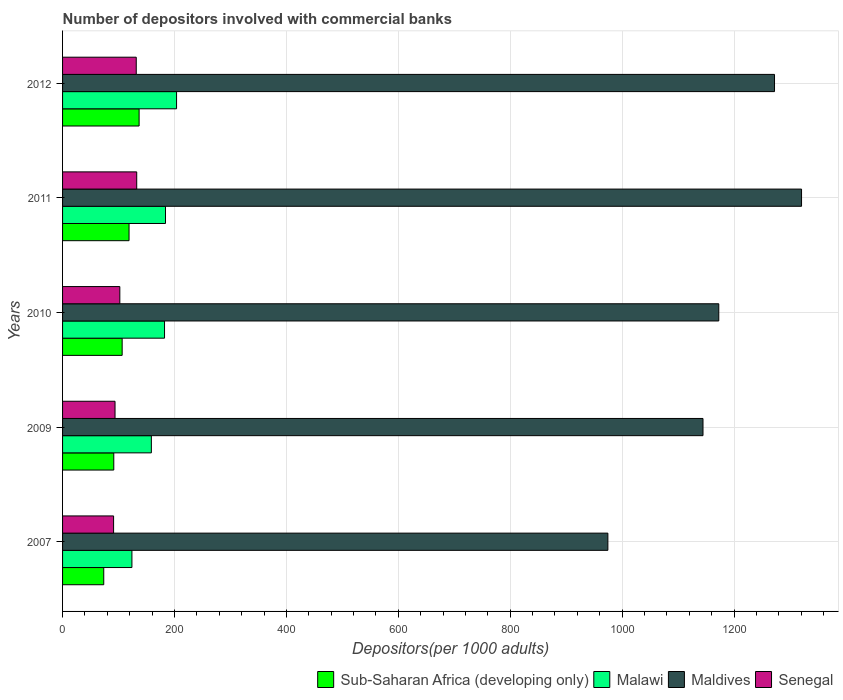Are the number of bars on each tick of the Y-axis equal?
Your response must be concise. Yes. How many bars are there on the 3rd tick from the top?
Keep it short and to the point. 4. In how many cases, is the number of bars for a given year not equal to the number of legend labels?
Offer a very short reply. 0. What is the number of depositors involved with commercial banks in Sub-Saharan Africa (developing only) in 2011?
Your response must be concise. 118.8. Across all years, what is the maximum number of depositors involved with commercial banks in Senegal?
Keep it short and to the point. 132.54. Across all years, what is the minimum number of depositors involved with commercial banks in Maldives?
Ensure brevity in your answer.  974.56. In which year was the number of depositors involved with commercial banks in Sub-Saharan Africa (developing only) maximum?
Provide a short and direct response. 2012. In which year was the number of depositors involved with commercial banks in Maldives minimum?
Give a very brief answer. 2007. What is the total number of depositors involved with commercial banks in Senegal in the graph?
Offer a very short reply. 551.53. What is the difference between the number of depositors involved with commercial banks in Maldives in 2007 and that in 2012?
Your response must be concise. -297.83. What is the difference between the number of depositors involved with commercial banks in Malawi in 2010 and the number of depositors involved with commercial banks in Maldives in 2011?
Provide a short and direct response. -1138.46. What is the average number of depositors involved with commercial banks in Senegal per year?
Keep it short and to the point. 110.31. In the year 2009, what is the difference between the number of depositors involved with commercial banks in Senegal and number of depositors involved with commercial banks in Malawi?
Offer a terse response. -64.92. What is the ratio of the number of depositors involved with commercial banks in Malawi in 2010 to that in 2012?
Offer a terse response. 0.89. Is the difference between the number of depositors involved with commercial banks in Senegal in 2010 and 2012 greater than the difference between the number of depositors involved with commercial banks in Malawi in 2010 and 2012?
Offer a very short reply. No. What is the difference between the highest and the second highest number of depositors involved with commercial banks in Sub-Saharan Africa (developing only)?
Provide a succinct answer. 17.98. What is the difference between the highest and the lowest number of depositors involved with commercial banks in Malawi?
Your answer should be very brief. 79.77. In how many years, is the number of depositors involved with commercial banks in Senegal greater than the average number of depositors involved with commercial banks in Senegal taken over all years?
Offer a terse response. 2. Is it the case that in every year, the sum of the number of depositors involved with commercial banks in Sub-Saharan Africa (developing only) and number of depositors involved with commercial banks in Senegal is greater than the sum of number of depositors involved with commercial banks in Malawi and number of depositors involved with commercial banks in Maldives?
Provide a succinct answer. No. What does the 4th bar from the top in 2012 represents?
Your answer should be very brief. Sub-Saharan Africa (developing only). What does the 2nd bar from the bottom in 2011 represents?
Provide a succinct answer. Malawi. Is it the case that in every year, the sum of the number of depositors involved with commercial banks in Senegal and number of depositors involved with commercial banks in Maldives is greater than the number of depositors involved with commercial banks in Sub-Saharan Africa (developing only)?
Make the answer very short. Yes. Are all the bars in the graph horizontal?
Keep it short and to the point. Yes. Does the graph contain grids?
Your answer should be compact. Yes. Where does the legend appear in the graph?
Provide a short and direct response. Bottom right. How are the legend labels stacked?
Your answer should be very brief. Horizontal. What is the title of the graph?
Offer a terse response. Number of depositors involved with commercial banks. What is the label or title of the X-axis?
Your answer should be compact. Depositors(per 1000 adults). What is the label or title of the Y-axis?
Offer a terse response. Years. What is the Depositors(per 1000 adults) in Sub-Saharan Africa (developing only) in 2007?
Ensure brevity in your answer.  73.6. What is the Depositors(per 1000 adults) of Malawi in 2007?
Provide a short and direct response. 123.95. What is the Depositors(per 1000 adults) of Maldives in 2007?
Make the answer very short. 974.56. What is the Depositors(per 1000 adults) in Senegal in 2007?
Your answer should be very brief. 91.2. What is the Depositors(per 1000 adults) of Sub-Saharan Africa (developing only) in 2009?
Keep it short and to the point. 91.54. What is the Depositors(per 1000 adults) in Malawi in 2009?
Make the answer very short. 158.69. What is the Depositors(per 1000 adults) of Maldives in 2009?
Make the answer very short. 1144.57. What is the Depositors(per 1000 adults) in Senegal in 2009?
Offer a terse response. 93.77. What is the Depositors(per 1000 adults) of Sub-Saharan Africa (developing only) in 2010?
Provide a succinct answer. 106.49. What is the Depositors(per 1000 adults) in Malawi in 2010?
Make the answer very short. 182.23. What is the Depositors(per 1000 adults) of Maldives in 2010?
Your answer should be very brief. 1172.79. What is the Depositors(per 1000 adults) of Senegal in 2010?
Your answer should be very brief. 102.32. What is the Depositors(per 1000 adults) in Sub-Saharan Africa (developing only) in 2011?
Provide a succinct answer. 118.8. What is the Depositors(per 1000 adults) in Malawi in 2011?
Provide a succinct answer. 183.96. What is the Depositors(per 1000 adults) of Maldives in 2011?
Ensure brevity in your answer.  1320.69. What is the Depositors(per 1000 adults) in Senegal in 2011?
Your answer should be compact. 132.54. What is the Depositors(per 1000 adults) in Sub-Saharan Africa (developing only) in 2012?
Offer a terse response. 136.78. What is the Depositors(per 1000 adults) of Malawi in 2012?
Give a very brief answer. 203.72. What is the Depositors(per 1000 adults) of Maldives in 2012?
Give a very brief answer. 1272.39. What is the Depositors(per 1000 adults) of Senegal in 2012?
Make the answer very short. 131.69. Across all years, what is the maximum Depositors(per 1000 adults) in Sub-Saharan Africa (developing only)?
Your response must be concise. 136.78. Across all years, what is the maximum Depositors(per 1000 adults) in Malawi?
Your answer should be very brief. 203.72. Across all years, what is the maximum Depositors(per 1000 adults) in Maldives?
Your answer should be very brief. 1320.69. Across all years, what is the maximum Depositors(per 1000 adults) in Senegal?
Offer a terse response. 132.54. Across all years, what is the minimum Depositors(per 1000 adults) of Sub-Saharan Africa (developing only)?
Your answer should be very brief. 73.6. Across all years, what is the minimum Depositors(per 1000 adults) in Malawi?
Your answer should be compact. 123.95. Across all years, what is the minimum Depositors(per 1000 adults) in Maldives?
Offer a very short reply. 974.56. Across all years, what is the minimum Depositors(per 1000 adults) of Senegal?
Your response must be concise. 91.2. What is the total Depositors(per 1000 adults) in Sub-Saharan Africa (developing only) in the graph?
Keep it short and to the point. 527.22. What is the total Depositors(per 1000 adults) of Malawi in the graph?
Provide a succinct answer. 852.55. What is the total Depositors(per 1000 adults) of Maldives in the graph?
Your answer should be very brief. 5884.99. What is the total Depositors(per 1000 adults) in Senegal in the graph?
Make the answer very short. 551.53. What is the difference between the Depositors(per 1000 adults) of Sub-Saharan Africa (developing only) in 2007 and that in 2009?
Your response must be concise. -17.95. What is the difference between the Depositors(per 1000 adults) in Malawi in 2007 and that in 2009?
Offer a very short reply. -34.74. What is the difference between the Depositors(per 1000 adults) of Maldives in 2007 and that in 2009?
Offer a terse response. -170.01. What is the difference between the Depositors(per 1000 adults) of Senegal in 2007 and that in 2009?
Offer a terse response. -2.56. What is the difference between the Depositors(per 1000 adults) of Sub-Saharan Africa (developing only) in 2007 and that in 2010?
Your answer should be very brief. -32.89. What is the difference between the Depositors(per 1000 adults) of Malawi in 2007 and that in 2010?
Keep it short and to the point. -58.28. What is the difference between the Depositors(per 1000 adults) of Maldives in 2007 and that in 2010?
Offer a very short reply. -198.23. What is the difference between the Depositors(per 1000 adults) in Senegal in 2007 and that in 2010?
Offer a very short reply. -11.12. What is the difference between the Depositors(per 1000 adults) of Sub-Saharan Africa (developing only) in 2007 and that in 2011?
Your answer should be very brief. -45.21. What is the difference between the Depositors(per 1000 adults) of Malawi in 2007 and that in 2011?
Your response must be concise. -60.01. What is the difference between the Depositors(per 1000 adults) of Maldives in 2007 and that in 2011?
Provide a succinct answer. -346.13. What is the difference between the Depositors(per 1000 adults) in Senegal in 2007 and that in 2011?
Your response must be concise. -41.33. What is the difference between the Depositors(per 1000 adults) of Sub-Saharan Africa (developing only) in 2007 and that in 2012?
Offer a terse response. -63.19. What is the difference between the Depositors(per 1000 adults) of Malawi in 2007 and that in 2012?
Give a very brief answer. -79.77. What is the difference between the Depositors(per 1000 adults) of Maldives in 2007 and that in 2012?
Offer a terse response. -297.83. What is the difference between the Depositors(per 1000 adults) of Senegal in 2007 and that in 2012?
Give a very brief answer. -40.49. What is the difference between the Depositors(per 1000 adults) of Sub-Saharan Africa (developing only) in 2009 and that in 2010?
Give a very brief answer. -14.95. What is the difference between the Depositors(per 1000 adults) of Malawi in 2009 and that in 2010?
Provide a short and direct response. -23.54. What is the difference between the Depositors(per 1000 adults) in Maldives in 2009 and that in 2010?
Provide a succinct answer. -28.22. What is the difference between the Depositors(per 1000 adults) of Senegal in 2009 and that in 2010?
Keep it short and to the point. -8.56. What is the difference between the Depositors(per 1000 adults) of Sub-Saharan Africa (developing only) in 2009 and that in 2011?
Offer a very short reply. -27.26. What is the difference between the Depositors(per 1000 adults) in Malawi in 2009 and that in 2011?
Your answer should be compact. -25.27. What is the difference between the Depositors(per 1000 adults) of Maldives in 2009 and that in 2011?
Make the answer very short. -176.13. What is the difference between the Depositors(per 1000 adults) in Senegal in 2009 and that in 2011?
Your answer should be very brief. -38.77. What is the difference between the Depositors(per 1000 adults) in Sub-Saharan Africa (developing only) in 2009 and that in 2012?
Offer a very short reply. -45.24. What is the difference between the Depositors(per 1000 adults) of Malawi in 2009 and that in 2012?
Provide a succinct answer. -45.04. What is the difference between the Depositors(per 1000 adults) in Maldives in 2009 and that in 2012?
Provide a short and direct response. -127.82. What is the difference between the Depositors(per 1000 adults) in Senegal in 2009 and that in 2012?
Make the answer very short. -37.92. What is the difference between the Depositors(per 1000 adults) in Sub-Saharan Africa (developing only) in 2010 and that in 2011?
Make the answer very short. -12.31. What is the difference between the Depositors(per 1000 adults) of Malawi in 2010 and that in 2011?
Your answer should be very brief. -1.73. What is the difference between the Depositors(per 1000 adults) of Maldives in 2010 and that in 2011?
Your answer should be compact. -147.91. What is the difference between the Depositors(per 1000 adults) in Senegal in 2010 and that in 2011?
Give a very brief answer. -30.21. What is the difference between the Depositors(per 1000 adults) of Sub-Saharan Africa (developing only) in 2010 and that in 2012?
Offer a terse response. -30.29. What is the difference between the Depositors(per 1000 adults) of Malawi in 2010 and that in 2012?
Provide a succinct answer. -21.49. What is the difference between the Depositors(per 1000 adults) of Maldives in 2010 and that in 2012?
Your response must be concise. -99.6. What is the difference between the Depositors(per 1000 adults) of Senegal in 2010 and that in 2012?
Your answer should be very brief. -29.37. What is the difference between the Depositors(per 1000 adults) in Sub-Saharan Africa (developing only) in 2011 and that in 2012?
Keep it short and to the point. -17.98. What is the difference between the Depositors(per 1000 adults) in Malawi in 2011 and that in 2012?
Provide a short and direct response. -19.76. What is the difference between the Depositors(per 1000 adults) in Maldives in 2011 and that in 2012?
Give a very brief answer. 48.3. What is the difference between the Depositors(per 1000 adults) in Senegal in 2011 and that in 2012?
Give a very brief answer. 0.84. What is the difference between the Depositors(per 1000 adults) in Sub-Saharan Africa (developing only) in 2007 and the Depositors(per 1000 adults) in Malawi in 2009?
Ensure brevity in your answer.  -85.09. What is the difference between the Depositors(per 1000 adults) of Sub-Saharan Africa (developing only) in 2007 and the Depositors(per 1000 adults) of Maldives in 2009?
Offer a very short reply. -1070.97. What is the difference between the Depositors(per 1000 adults) of Sub-Saharan Africa (developing only) in 2007 and the Depositors(per 1000 adults) of Senegal in 2009?
Ensure brevity in your answer.  -20.17. What is the difference between the Depositors(per 1000 adults) in Malawi in 2007 and the Depositors(per 1000 adults) in Maldives in 2009?
Your answer should be very brief. -1020.61. What is the difference between the Depositors(per 1000 adults) in Malawi in 2007 and the Depositors(per 1000 adults) in Senegal in 2009?
Your answer should be very brief. 30.18. What is the difference between the Depositors(per 1000 adults) in Maldives in 2007 and the Depositors(per 1000 adults) in Senegal in 2009?
Ensure brevity in your answer.  880.79. What is the difference between the Depositors(per 1000 adults) of Sub-Saharan Africa (developing only) in 2007 and the Depositors(per 1000 adults) of Malawi in 2010?
Keep it short and to the point. -108.63. What is the difference between the Depositors(per 1000 adults) of Sub-Saharan Africa (developing only) in 2007 and the Depositors(per 1000 adults) of Maldives in 2010?
Offer a very short reply. -1099.19. What is the difference between the Depositors(per 1000 adults) of Sub-Saharan Africa (developing only) in 2007 and the Depositors(per 1000 adults) of Senegal in 2010?
Provide a short and direct response. -28.73. What is the difference between the Depositors(per 1000 adults) in Malawi in 2007 and the Depositors(per 1000 adults) in Maldives in 2010?
Offer a very short reply. -1048.84. What is the difference between the Depositors(per 1000 adults) of Malawi in 2007 and the Depositors(per 1000 adults) of Senegal in 2010?
Your answer should be very brief. 21.63. What is the difference between the Depositors(per 1000 adults) of Maldives in 2007 and the Depositors(per 1000 adults) of Senegal in 2010?
Your answer should be very brief. 872.23. What is the difference between the Depositors(per 1000 adults) of Sub-Saharan Africa (developing only) in 2007 and the Depositors(per 1000 adults) of Malawi in 2011?
Ensure brevity in your answer.  -110.36. What is the difference between the Depositors(per 1000 adults) in Sub-Saharan Africa (developing only) in 2007 and the Depositors(per 1000 adults) in Maldives in 2011?
Provide a succinct answer. -1247.1. What is the difference between the Depositors(per 1000 adults) of Sub-Saharan Africa (developing only) in 2007 and the Depositors(per 1000 adults) of Senegal in 2011?
Give a very brief answer. -58.94. What is the difference between the Depositors(per 1000 adults) in Malawi in 2007 and the Depositors(per 1000 adults) in Maldives in 2011?
Ensure brevity in your answer.  -1196.74. What is the difference between the Depositors(per 1000 adults) of Malawi in 2007 and the Depositors(per 1000 adults) of Senegal in 2011?
Provide a short and direct response. -8.59. What is the difference between the Depositors(per 1000 adults) in Maldives in 2007 and the Depositors(per 1000 adults) in Senegal in 2011?
Keep it short and to the point. 842.02. What is the difference between the Depositors(per 1000 adults) of Sub-Saharan Africa (developing only) in 2007 and the Depositors(per 1000 adults) of Malawi in 2012?
Ensure brevity in your answer.  -130.13. What is the difference between the Depositors(per 1000 adults) in Sub-Saharan Africa (developing only) in 2007 and the Depositors(per 1000 adults) in Maldives in 2012?
Make the answer very short. -1198.79. What is the difference between the Depositors(per 1000 adults) in Sub-Saharan Africa (developing only) in 2007 and the Depositors(per 1000 adults) in Senegal in 2012?
Provide a short and direct response. -58.1. What is the difference between the Depositors(per 1000 adults) of Malawi in 2007 and the Depositors(per 1000 adults) of Maldives in 2012?
Provide a short and direct response. -1148.44. What is the difference between the Depositors(per 1000 adults) of Malawi in 2007 and the Depositors(per 1000 adults) of Senegal in 2012?
Offer a terse response. -7.74. What is the difference between the Depositors(per 1000 adults) of Maldives in 2007 and the Depositors(per 1000 adults) of Senegal in 2012?
Ensure brevity in your answer.  842.86. What is the difference between the Depositors(per 1000 adults) of Sub-Saharan Africa (developing only) in 2009 and the Depositors(per 1000 adults) of Malawi in 2010?
Offer a terse response. -90.69. What is the difference between the Depositors(per 1000 adults) of Sub-Saharan Africa (developing only) in 2009 and the Depositors(per 1000 adults) of Maldives in 2010?
Provide a succinct answer. -1081.24. What is the difference between the Depositors(per 1000 adults) of Sub-Saharan Africa (developing only) in 2009 and the Depositors(per 1000 adults) of Senegal in 2010?
Your response must be concise. -10.78. What is the difference between the Depositors(per 1000 adults) of Malawi in 2009 and the Depositors(per 1000 adults) of Maldives in 2010?
Provide a succinct answer. -1014.1. What is the difference between the Depositors(per 1000 adults) in Malawi in 2009 and the Depositors(per 1000 adults) in Senegal in 2010?
Offer a terse response. 56.36. What is the difference between the Depositors(per 1000 adults) of Maldives in 2009 and the Depositors(per 1000 adults) of Senegal in 2010?
Keep it short and to the point. 1042.24. What is the difference between the Depositors(per 1000 adults) of Sub-Saharan Africa (developing only) in 2009 and the Depositors(per 1000 adults) of Malawi in 2011?
Provide a short and direct response. -92.42. What is the difference between the Depositors(per 1000 adults) of Sub-Saharan Africa (developing only) in 2009 and the Depositors(per 1000 adults) of Maldives in 2011?
Give a very brief answer. -1229.15. What is the difference between the Depositors(per 1000 adults) in Sub-Saharan Africa (developing only) in 2009 and the Depositors(per 1000 adults) in Senegal in 2011?
Ensure brevity in your answer.  -40.99. What is the difference between the Depositors(per 1000 adults) of Malawi in 2009 and the Depositors(per 1000 adults) of Maldives in 2011?
Provide a short and direct response. -1162.01. What is the difference between the Depositors(per 1000 adults) of Malawi in 2009 and the Depositors(per 1000 adults) of Senegal in 2011?
Provide a succinct answer. 26.15. What is the difference between the Depositors(per 1000 adults) of Maldives in 2009 and the Depositors(per 1000 adults) of Senegal in 2011?
Your answer should be compact. 1012.03. What is the difference between the Depositors(per 1000 adults) in Sub-Saharan Africa (developing only) in 2009 and the Depositors(per 1000 adults) in Malawi in 2012?
Provide a short and direct response. -112.18. What is the difference between the Depositors(per 1000 adults) of Sub-Saharan Africa (developing only) in 2009 and the Depositors(per 1000 adults) of Maldives in 2012?
Your answer should be very brief. -1180.84. What is the difference between the Depositors(per 1000 adults) in Sub-Saharan Africa (developing only) in 2009 and the Depositors(per 1000 adults) in Senegal in 2012?
Keep it short and to the point. -40.15. What is the difference between the Depositors(per 1000 adults) of Malawi in 2009 and the Depositors(per 1000 adults) of Maldives in 2012?
Offer a terse response. -1113.7. What is the difference between the Depositors(per 1000 adults) in Malawi in 2009 and the Depositors(per 1000 adults) in Senegal in 2012?
Provide a succinct answer. 26.99. What is the difference between the Depositors(per 1000 adults) in Maldives in 2009 and the Depositors(per 1000 adults) in Senegal in 2012?
Provide a succinct answer. 1012.87. What is the difference between the Depositors(per 1000 adults) in Sub-Saharan Africa (developing only) in 2010 and the Depositors(per 1000 adults) in Malawi in 2011?
Offer a terse response. -77.47. What is the difference between the Depositors(per 1000 adults) in Sub-Saharan Africa (developing only) in 2010 and the Depositors(per 1000 adults) in Maldives in 2011?
Offer a terse response. -1214.2. What is the difference between the Depositors(per 1000 adults) in Sub-Saharan Africa (developing only) in 2010 and the Depositors(per 1000 adults) in Senegal in 2011?
Provide a short and direct response. -26.05. What is the difference between the Depositors(per 1000 adults) in Malawi in 2010 and the Depositors(per 1000 adults) in Maldives in 2011?
Keep it short and to the point. -1138.46. What is the difference between the Depositors(per 1000 adults) of Malawi in 2010 and the Depositors(per 1000 adults) of Senegal in 2011?
Ensure brevity in your answer.  49.69. What is the difference between the Depositors(per 1000 adults) of Maldives in 2010 and the Depositors(per 1000 adults) of Senegal in 2011?
Offer a terse response. 1040.25. What is the difference between the Depositors(per 1000 adults) in Sub-Saharan Africa (developing only) in 2010 and the Depositors(per 1000 adults) in Malawi in 2012?
Offer a terse response. -97.23. What is the difference between the Depositors(per 1000 adults) of Sub-Saharan Africa (developing only) in 2010 and the Depositors(per 1000 adults) of Maldives in 2012?
Offer a very short reply. -1165.9. What is the difference between the Depositors(per 1000 adults) in Sub-Saharan Africa (developing only) in 2010 and the Depositors(per 1000 adults) in Senegal in 2012?
Offer a terse response. -25.2. What is the difference between the Depositors(per 1000 adults) of Malawi in 2010 and the Depositors(per 1000 adults) of Maldives in 2012?
Offer a terse response. -1090.16. What is the difference between the Depositors(per 1000 adults) in Malawi in 2010 and the Depositors(per 1000 adults) in Senegal in 2012?
Offer a very short reply. 50.54. What is the difference between the Depositors(per 1000 adults) of Maldives in 2010 and the Depositors(per 1000 adults) of Senegal in 2012?
Your response must be concise. 1041.09. What is the difference between the Depositors(per 1000 adults) in Sub-Saharan Africa (developing only) in 2011 and the Depositors(per 1000 adults) in Malawi in 2012?
Offer a very short reply. -84.92. What is the difference between the Depositors(per 1000 adults) of Sub-Saharan Africa (developing only) in 2011 and the Depositors(per 1000 adults) of Maldives in 2012?
Ensure brevity in your answer.  -1153.58. What is the difference between the Depositors(per 1000 adults) of Sub-Saharan Africa (developing only) in 2011 and the Depositors(per 1000 adults) of Senegal in 2012?
Your answer should be compact. -12.89. What is the difference between the Depositors(per 1000 adults) of Malawi in 2011 and the Depositors(per 1000 adults) of Maldives in 2012?
Keep it short and to the point. -1088.43. What is the difference between the Depositors(per 1000 adults) in Malawi in 2011 and the Depositors(per 1000 adults) in Senegal in 2012?
Provide a short and direct response. 52.27. What is the difference between the Depositors(per 1000 adults) of Maldives in 2011 and the Depositors(per 1000 adults) of Senegal in 2012?
Offer a terse response. 1189. What is the average Depositors(per 1000 adults) of Sub-Saharan Africa (developing only) per year?
Provide a succinct answer. 105.44. What is the average Depositors(per 1000 adults) in Malawi per year?
Provide a succinct answer. 170.51. What is the average Depositors(per 1000 adults) in Maldives per year?
Your answer should be compact. 1177. What is the average Depositors(per 1000 adults) of Senegal per year?
Your answer should be compact. 110.31. In the year 2007, what is the difference between the Depositors(per 1000 adults) in Sub-Saharan Africa (developing only) and Depositors(per 1000 adults) in Malawi?
Provide a succinct answer. -50.35. In the year 2007, what is the difference between the Depositors(per 1000 adults) of Sub-Saharan Africa (developing only) and Depositors(per 1000 adults) of Maldives?
Ensure brevity in your answer.  -900.96. In the year 2007, what is the difference between the Depositors(per 1000 adults) in Sub-Saharan Africa (developing only) and Depositors(per 1000 adults) in Senegal?
Provide a succinct answer. -17.61. In the year 2007, what is the difference between the Depositors(per 1000 adults) of Malawi and Depositors(per 1000 adults) of Maldives?
Your answer should be very brief. -850.61. In the year 2007, what is the difference between the Depositors(per 1000 adults) in Malawi and Depositors(per 1000 adults) in Senegal?
Provide a succinct answer. 32.75. In the year 2007, what is the difference between the Depositors(per 1000 adults) in Maldives and Depositors(per 1000 adults) in Senegal?
Offer a terse response. 883.35. In the year 2009, what is the difference between the Depositors(per 1000 adults) of Sub-Saharan Africa (developing only) and Depositors(per 1000 adults) of Malawi?
Offer a very short reply. -67.14. In the year 2009, what is the difference between the Depositors(per 1000 adults) of Sub-Saharan Africa (developing only) and Depositors(per 1000 adults) of Maldives?
Keep it short and to the point. -1053.02. In the year 2009, what is the difference between the Depositors(per 1000 adults) of Sub-Saharan Africa (developing only) and Depositors(per 1000 adults) of Senegal?
Make the answer very short. -2.23. In the year 2009, what is the difference between the Depositors(per 1000 adults) in Malawi and Depositors(per 1000 adults) in Maldives?
Keep it short and to the point. -985.88. In the year 2009, what is the difference between the Depositors(per 1000 adults) of Malawi and Depositors(per 1000 adults) of Senegal?
Provide a succinct answer. 64.92. In the year 2009, what is the difference between the Depositors(per 1000 adults) in Maldives and Depositors(per 1000 adults) in Senegal?
Provide a short and direct response. 1050.8. In the year 2010, what is the difference between the Depositors(per 1000 adults) of Sub-Saharan Africa (developing only) and Depositors(per 1000 adults) of Malawi?
Ensure brevity in your answer.  -75.74. In the year 2010, what is the difference between the Depositors(per 1000 adults) in Sub-Saharan Africa (developing only) and Depositors(per 1000 adults) in Maldives?
Keep it short and to the point. -1066.3. In the year 2010, what is the difference between the Depositors(per 1000 adults) of Sub-Saharan Africa (developing only) and Depositors(per 1000 adults) of Senegal?
Your answer should be very brief. 4.17. In the year 2010, what is the difference between the Depositors(per 1000 adults) in Malawi and Depositors(per 1000 adults) in Maldives?
Give a very brief answer. -990.56. In the year 2010, what is the difference between the Depositors(per 1000 adults) of Malawi and Depositors(per 1000 adults) of Senegal?
Your answer should be very brief. 79.91. In the year 2010, what is the difference between the Depositors(per 1000 adults) in Maldives and Depositors(per 1000 adults) in Senegal?
Offer a terse response. 1070.46. In the year 2011, what is the difference between the Depositors(per 1000 adults) in Sub-Saharan Africa (developing only) and Depositors(per 1000 adults) in Malawi?
Ensure brevity in your answer.  -65.16. In the year 2011, what is the difference between the Depositors(per 1000 adults) of Sub-Saharan Africa (developing only) and Depositors(per 1000 adults) of Maldives?
Keep it short and to the point. -1201.89. In the year 2011, what is the difference between the Depositors(per 1000 adults) of Sub-Saharan Africa (developing only) and Depositors(per 1000 adults) of Senegal?
Your response must be concise. -13.73. In the year 2011, what is the difference between the Depositors(per 1000 adults) of Malawi and Depositors(per 1000 adults) of Maldives?
Keep it short and to the point. -1136.73. In the year 2011, what is the difference between the Depositors(per 1000 adults) of Malawi and Depositors(per 1000 adults) of Senegal?
Provide a succinct answer. 51.42. In the year 2011, what is the difference between the Depositors(per 1000 adults) in Maldives and Depositors(per 1000 adults) in Senegal?
Make the answer very short. 1188.16. In the year 2012, what is the difference between the Depositors(per 1000 adults) in Sub-Saharan Africa (developing only) and Depositors(per 1000 adults) in Malawi?
Your answer should be compact. -66.94. In the year 2012, what is the difference between the Depositors(per 1000 adults) of Sub-Saharan Africa (developing only) and Depositors(per 1000 adults) of Maldives?
Provide a succinct answer. -1135.6. In the year 2012, what is the difference between the Depositors(per 1000 adults) in Sub-Saharan Africa (developing only) and Depositors(per 1000 adults) in Senegal?
Ensure brevity in your answer.  5.09. In the year 2012, what is the difference between the Depositors(per 1000 adults) in Malawi and Depositors(per 1000 adults) in Maldives?
Offer a very short reply. -1068.66. In the year 2012, what is the difference between the Depositors(per 1000 adults) in Malawi and Depositors(per 1000 adults) in Senegal?
Your answer should be very brief. 72.03. In the year 2012, what is the difference between the Depositors(per 1000 adults) in Maldives and Depositors(per 1000 adults) in Senegal?
Keep it short and to the point. 1140.69. What is the ratio of the Depositors(per 1000 adults) in Sub-Saharan Africa (developing only) in 2007 to that in 2009?
Make the answer very short. 0.8. What is the ratio of the Depositors(per 1000 adults) of Malawi in 2007 to that in 2009?
Offer a terse response. 0.78. What is the ratio of the Depositors(per 1000 adults) in Maldives in 2007 to that in 2009?
Give a very brief answer. 0.85. What is the ratio of the Depositors(per 1000 adults) in Senegal in 2007 to that in 2009?
Your answer should be very brief. 0.97. What is the ratio of the Depositors(per 1000 adults) of Sub-Saharan Africa (developing only) in 2007 to that in 2010?
Offer a terse response. 0.69. What is the ratio of the Depositors(per 1000 adults) of Malawi in 2007 to that in 2010?
Your answer should be very brief. 0.68. What is the ratio of the Depositors(per 1000 adults) of Maldives in 2007 to that in 2010?
Make the answer very short. 0.83. What is the ratio of the Depositors(per 1000 adults) in Senegal in 2007 to that in 2010?
Ensure brevity in your answer.  0.89. What is the ratio of the Depositors(per 1000 adults) of Sub-Saharan Africa (developing only) in 2007 to that in 2011?
Give a very brief answer. 0.62. What is the ratio of the Depositors(per 1000 adults) in Malawi in 2007 to that in 2011?
Provide a succinct answer. 0.67. What is the ratio of the Depositors(per 1000 adults) in Maldives in 2007 to that in 2011?
Give a very brief answer. 0.74. What is the ratio of the Depositors(per 1000 adults) in Senegal in 2007 to that in 2011?
Give a very brief answer. 0.69. What is the ratio of the Depositors(per 1000 adults) of Sub-Saharan Africa (developing only) in 2007 to that in 2012?
Your answer should be very brief. 0.54. What is the ratio of the Depositors(per 1000 adults) in Malawi in 2007 to that in 2012?
Your response must be concise. 0.61. What is the ratio of the Depositors(per 1000 adults) of Maldives in 2007 to that in 2012?
Provide a succinct answer. 0.77. What is the ratio of the Depositors(per 1000 adults) in Senegal in 2007 to that in 2012?
Offer a terse response. 0.69. What is the ratio of the Depositors(per 1000 adults) in Sub-Saharan Africa (developing only) in 2009 to that in 2010?
Your answer should be very brief. 0.86. What is the ratio of the Depositors(per 1000 adults) of Malawi in 2009 to that in 2010?
Give a very brief answer. 0.87. What is the ratio of the Depositors(per 1000 adults) in Maldives in 2009 to that in 2010?
Provide a short and direct response. 0.98. What is the ratio of the Depositors(per 1000 adults) in Senegal in 2009 to that in 2010?
Offer a terse response. 0.92. What is the ratio of the Depositors(per 1000 adults) of Sub-Saharan Africa (developing only) in 2009 to that in 2011?
Provide a short and direct response. 0.77. What is the ratio of the Depositors(per 1000 adults) in Malawi in 2009 to that in 2011?
Provide a short and direct response. 0.86. What is the ratio of the Depositors(per 1000 adults) in Maldives in 2009 to that in 2011?
Offer a very short reply. 0.87. What is the ratio of the Depositors(per 1000 adults) of Senegal in 2009 to that in 2011?
Give a very brief answer. 0.71. What is the ratio of the Depositors(per 1000 adults) of Sub-Saharan Africa (developing only) in 2009 to that in 2012?
Provide a short and direct response. 0.67. What is the ratio of the Depositors(per 1000 adults) in Malawi in 2009 to that in 2012?
Provide a short and direct response. 0.78. What is the ratio of the Depositors(per 1000 adults) of Maldives in 2009 to that in 2012?
Your response must be concise. 0.9. What is the ratio of the Depositors(per 1000 adults) of Senegal in 2009 to that in 2012?
Your response must be concise. 0.71. What is the ratio of the Depositors(per 1000 adults) of Sub-Saharan Africa (developing only) in 2010 to that in 2011?
Give a very brief answer. 0.9. What is the ratio of the Depositors(per 1000 adults) of Malawi in 2010 to that in 2011?
Keep it short and to the point. 0.99. What is the ratio of the Depositors(per 1000 adults) of Maldives in 2010 to that in 2011?
Your answer should be very brief. 0.89. What is the ratio of the Depositors(per 1000 adults) in Senegal in 2010 to that in 2011?
Offer a terse response. 0.77. What is the ratio of the Depositors(per 1000 adults) in Sub-Saharan Africa (developing only) in 2010 to that in 2012?
Make the answer very short. 0.78. What is the ratio of the Depositors(per 1000 adults) in Malawi in 2010 to that in 2012?
Offer a very short reply. 0.89. What is the ratio of the Depositors(per 1000 adults) of Maldives in 2010 to that in 2012?
Offer a terse response. 0.92. What is the ratio of the Depositors(per 1000 adults) of Senegal in 2010 to that in 2012?
Provide a short and direct response. 0.78. What is the ratio of the Depositors(per 1000 adults) of Sub-Saharan Africa (developing only) in 2011 to that in 2012?
Make the answer very short. 0.87. What is the ratio of the Depositors(per 1000 adults) of Malawi in 2011 to that in 2012?
Offer a very short reply. 0.9. What is the ratio of the Depositors(per 1000 adults) of Maldives in 2011 to that in 2012?
Make the answer very short. 1.04. What is the ratio of the Depositors(per 1000 adults) of Senegal in 2011 to that in 2012?
Keep it short and to the point. 1.01. What is the difference between the highest and the second highest Depositors(per 1000 adults) of Sub-Saharan Africa (developing only)?
Your response must be concise. 17.98. What is the difference between the highest and the second highest Depositors(per 1000 adults) of Malawi?
Your answer should be compact. 19.76. What is the difference between the highest and the second highest Depositors(per 1000 adults) of Maldives?
Offer a very short reply. 48.3. What is the difference between the highest and the second highest Depositors(per 1000 adults) in Senegal?
Provide a succinct answer. 0.84. What is the difference between the highest and the lowest Depositors(per 1000 adults) of Sub-Saharan Africa (developing only)?
Offer a very short reply. 63.19. What is the difference between the highest and the lowest Depositors(per 1000 adults) of Malawi?
Make the answer very short. 79.77. What is the difference between the highest and the lowest Depositors(per 1000 adults) in Maldives?
Provide a succinct answer. 346.13. What is the difference between the highest and the lowest Depositors(per 1000 adults) in Senegal?
Offer a very short reply. 41.33. 